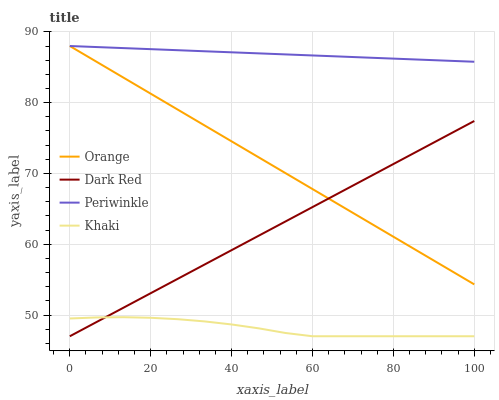Does Khaki have the minimum area under the curve?
Answer yes or no. Yes. Does Periwinkle have the maximum area under the curve?
Answer yes or no. Yes. Does Dark Red have the minimum area under the curve?
Answer yes or no. No. Does Dark Red have the maximum area under the curve?
Answer yes or no. No. Is Periwinkle the smoothest?
Answer yes or no. Yes. Is Khaki the roughest?
Answer yes or no. Yes. Is Dark Red the smoothest?
Answer yes or no. No. Is Dark Red the roughest?
Answer yes or no. No. Does Dark Red have the lowest value?
Answer yes or no. Yes. Does Periwinkle have the lowest value?
Answer yes or no. No. Does Periwinkle have the highest value?
Answer yes or no. Yes. Does Dark Red have the highest value?
Answer yes or no. No. Is Khaki less than Periwinkle?
Answer yes or no. Yes. Is Orange greater than Khaki?
Answer yes or no. Yes. Does Dark Red intersect Orange?
Answer yes or no. Yes. Is Dark Red less than Orange?
Answer yes or no. No. Is Dark Red greater than Orange?
Answer yes or no. No. Does Khaki intersect Periwinkle?
Answer yes or no. No. 